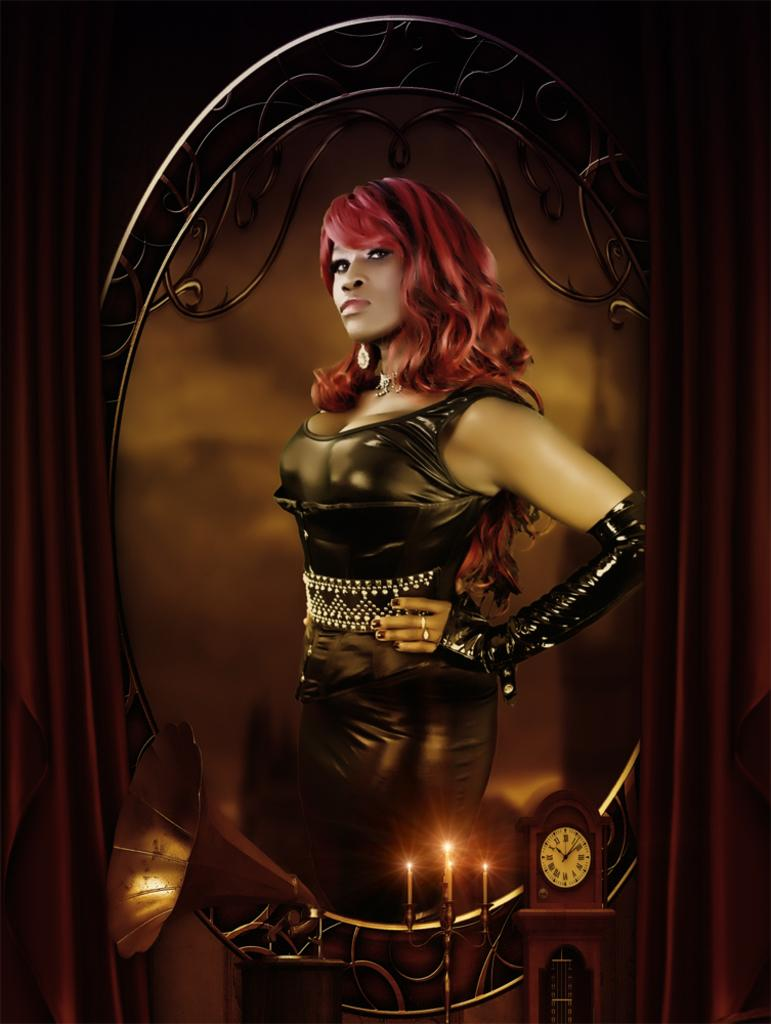Who is present in the image? There is a woman in the image. What objects can be seen related to lighting in the image? There are candles on a stand in the image. What time-related object is visible in the image? There is a clock in the image. What device is present for playing music in the image? There is a music system in the image. What type of window treatment is visible in the image? There are curtains in the image. Can you describe the car that is parked outside the window in the image? There is no car visible in the image; it only shows a woman, candles, a clock, a music system, and curtains. 